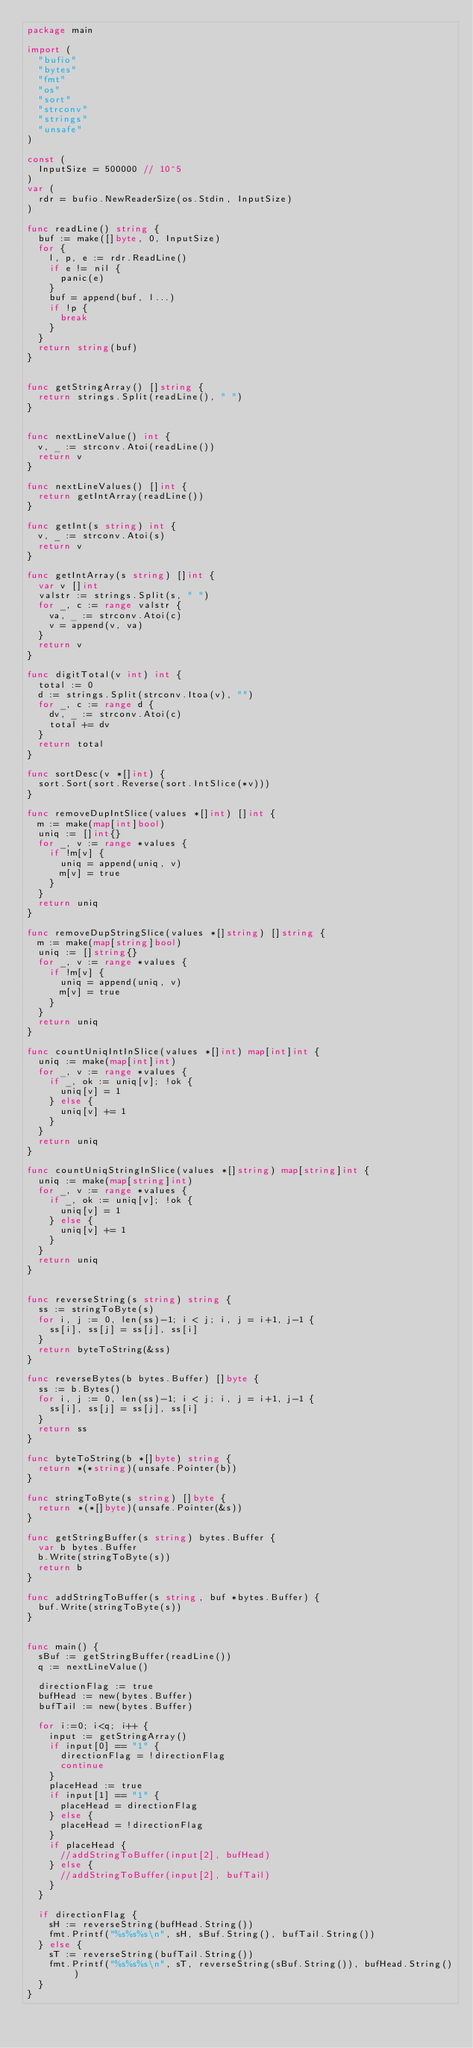<code> <loc_0><loc_0><loc_500><loc_500><_Go_>package main

import (
  "bufio"
  "bytes"
  "fmt"
  "os"
  "sort"
  "strconv"
  "strings"
  "unsafe"
)

const (
  InputSize = 500000 // 10^5
)
var (
  rdr = bufio.NewReaderSize(os.Stdin, InputSize)
)

func readLine() string {
  buf := make([]byte, 0, InputSize)
  for {
    l, p, e := rdr.ReadLine()
    if e != nil {
      panic(e)
    }
    buf = append(buf, l...)
    if !p {
      break
    }
  }
  return string(buf)
}


func getStringArray() []string {
  return strings.Split(readLine(), " ")
}


func nextLineValue() int {
  v, _ := strconv.Atoi(readLine())
  return v
}

func nextLineValues() []int {
  return getIntArray(readLine())
}

func getInt(s string) int {
  v, _ := strconv.Atoi(s)
  return v
}

func getIntArray(s string) []int {
  var v []int
  valstr := strings.Split(s, " ")
  for _, c := range valstr {
    va, _ := strconv.Atoi(c)
    v = append(v, va)
  }
  return v
}

func digitTotal(v int) int {
  total := 0
  d := strings.Split(strconv.Itoa(v), "")
  for _, c := range d {
    dv, _ := strconv.Atoi(c)
    total += dv
  }
  return total
}

func sortDesc(v *[]int) {
  sort.Sort(sort.Reverse(sort.IntSlice(*v)))
}

func removeDupIntSlice(values *[]int) []int {
  m := make(map[int]bool)
  uniq := []int{}
  for _, v := range *values {
    if !m[v] {
      uniq = append(uniq, v)
      m[v] = true
    }
  }
  return uniq
}

func removeDupStringSlice(values *[]string) []string {
  m := make(map[string]bool)
  uniq := []string{}
  for _, v := range *values {
    if !m[v] {
      uniq = append(uniq, v)
      m[v] = true
    }
  }
  return uniq
}

func countUniqIntInSlice(values *[]int) map[int]int {
  uniq := make(map[int]int)
  for _, v := range *values {
    if _, ok := uniq[v]; !ok {
      uniq[v] = 1
    } else {
      uniq[v] += 1
    }
  }
  return uniq
}

func countUniqStringInSlice(values *[]string) map[string]int {
  uniq := make(map[string]int)
  for _, v := range *values {
    if _, ok := uniq[v]; !ok {
      uniq[v] = 1
    } else {
      uniq[v] += 1
    }
  }
  return uniq
}


func reverseString(s string) string {
  ss := stringToByte(s)
  for i, j := 0, len(ss)-1; i < j; i, j = i+1, j-1 {
    ss[i], ss[j] = ss[j], ss[i]
  }
  return byteToString(&ss)
}

func reverseBytes(b bytes.Buffer) []byte {
  ss := b.Bytes()
  for i, j := 0, len(ss)-1; i < j; i, j = i+1, j-1 {
    ss[i], ss[j] = ss[j], ss[i]
  }
  return ss
}

func byteToString(b *[]byte) string {
  return *(*string)(unsafe.Pointer(b))
}

func stringToByte(s string) []byte {
  return *(*[]byte)(unsafe.Pointer(&s))
}

func getStringBuffer(s string) bytes.Buffer {
  var b bytes.Buffer
  b.Write(stringToByte(s))
  return b
}

func addStringToBuffer(s string, buf *bytes.Buffer) {
  buf.Write(stringToByte(s))
}


func main() {
  sBuf := getStringBuffer(readLine())
  q := nextLineValue()

  directionFlag := true
  bufHead := new(bytes.Buffer)
  bufTail := new(bytes.Buffer)

  for i:=0; i<q; i++ {
    input := getStringArray()
    if input[0] == "1" {
      directionFlag = !directionFlag
      continue
    }
    placeHead := true
    if input[1] == "1" {
      placeHead = directionFlag
    } else {
      placeHead = !directionFlag
    }
    if placeHead {
      //addStringToBuffer(input[2], bufHead)
    } else {
      //addStringToBuffer(input[2], bufTail)
    }
  }

  if directionFlag {
    sH := reverseString(bufHead.String())
    fmt.Printf("%s%s%s\n", sH, sBuf.String(), bufTail.String())
  } else {
    sT := reverseString(bufTail.String())
    fmt.Printf("%s%s%s\n", sT, reverseString(sBuf.String()), bufHead.String())
  }
}
</code> 